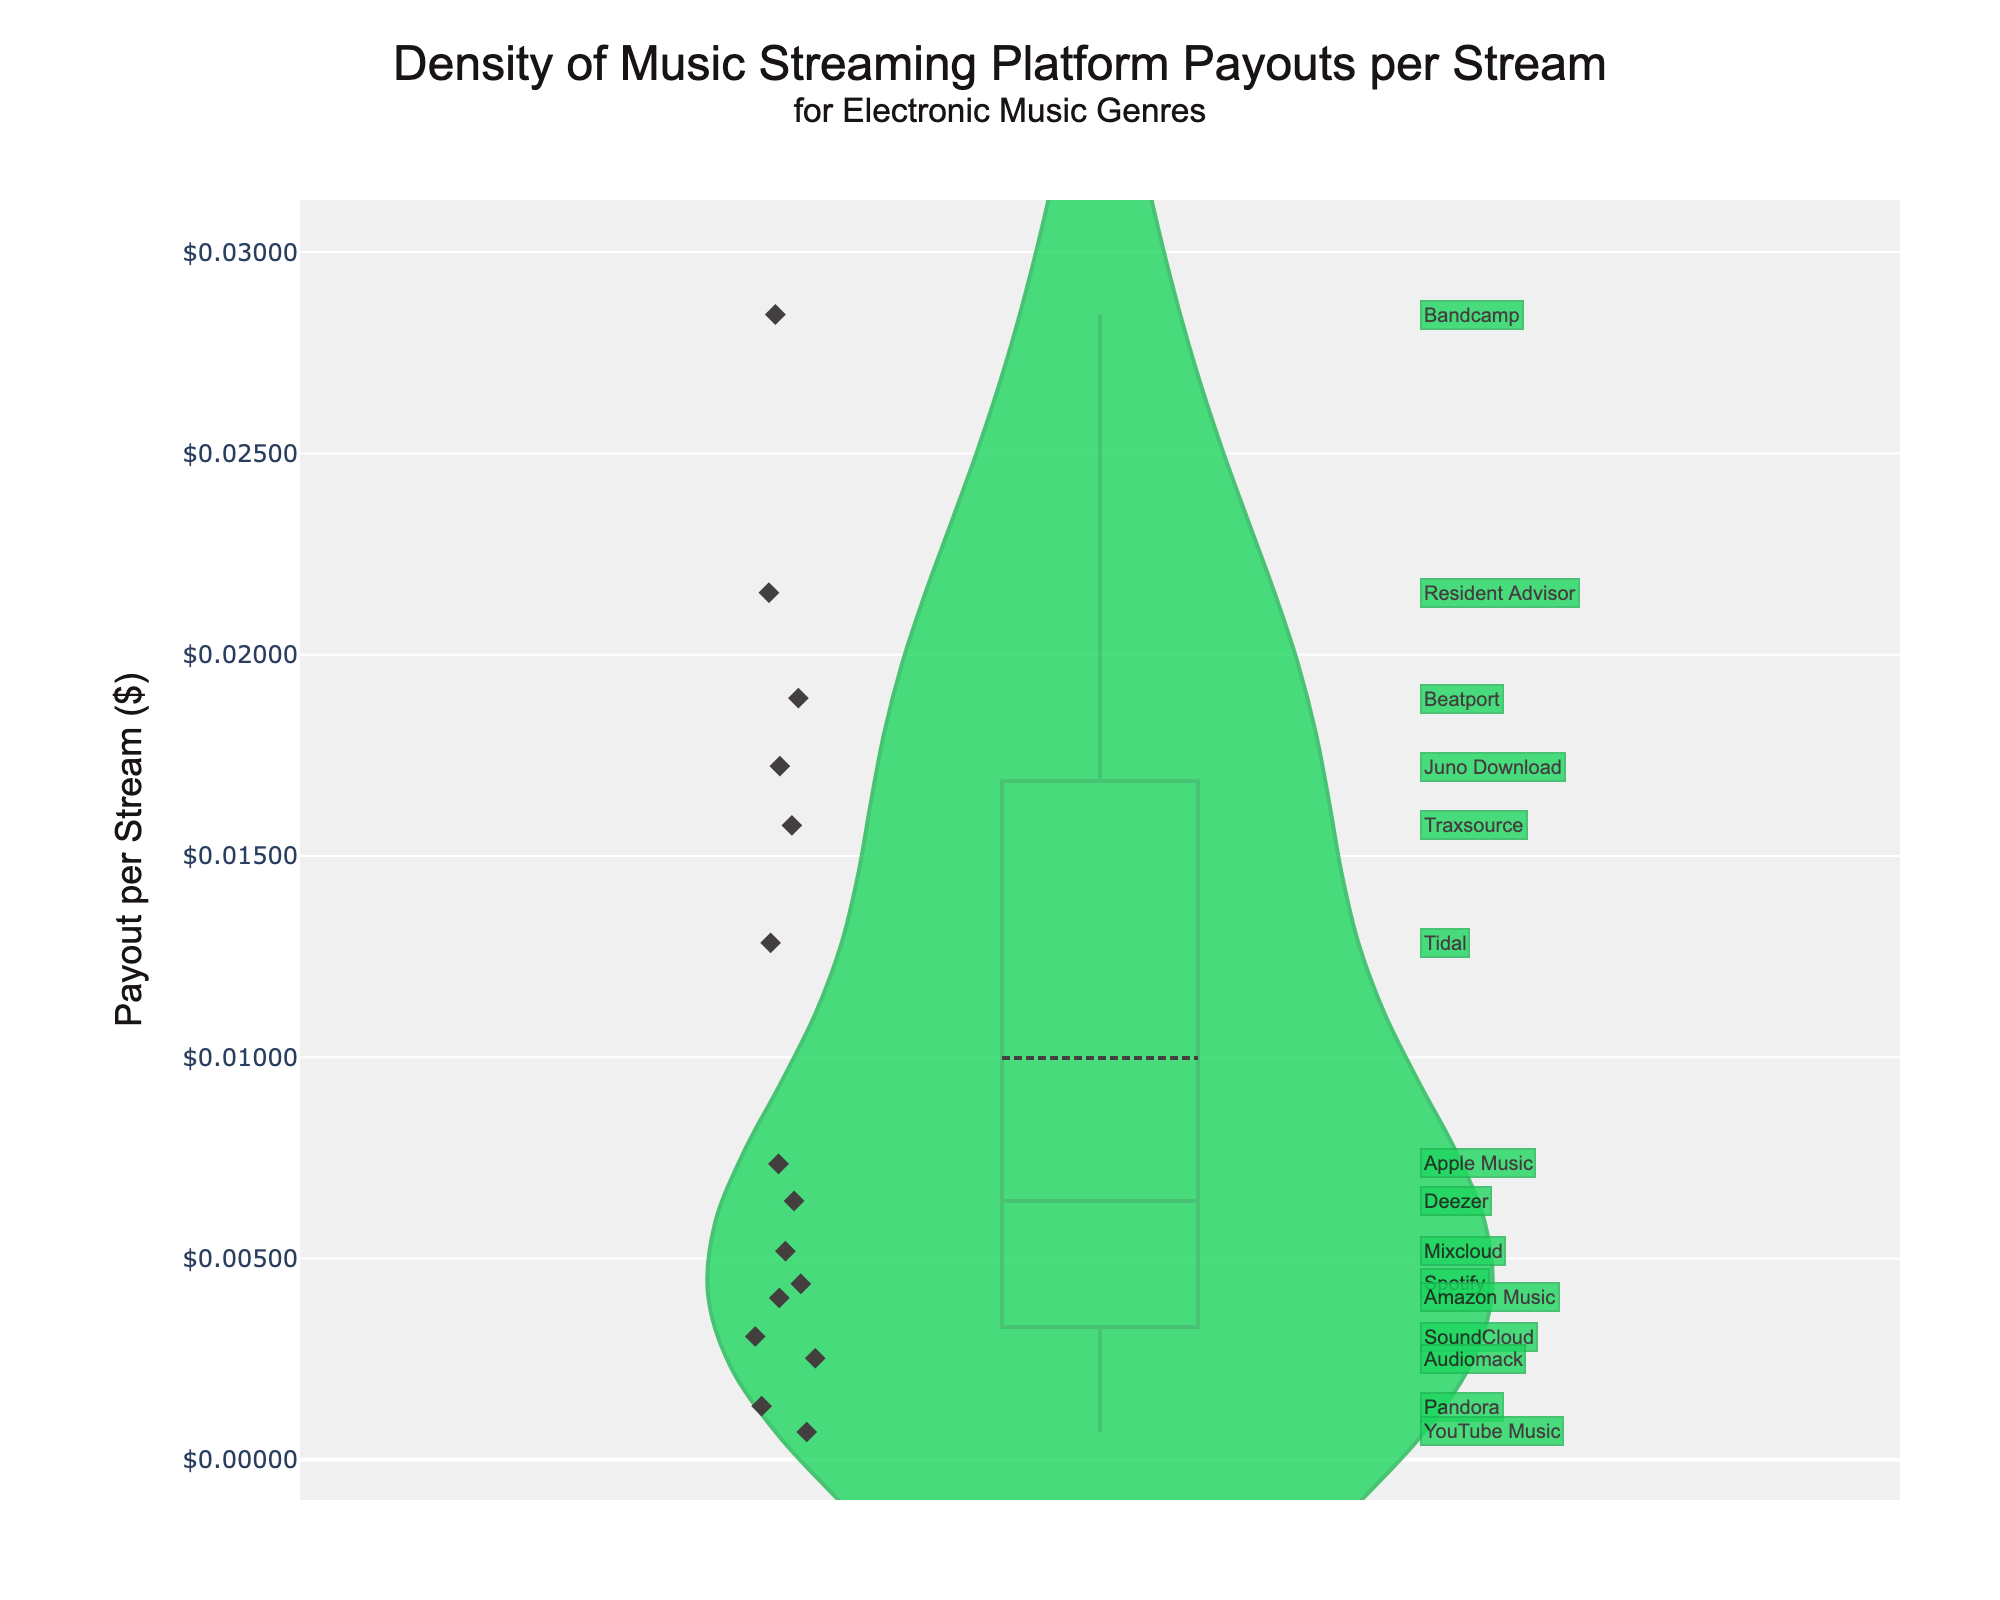What is the highest payout per stream among the platforms? The highest point in the density plot represents the largest payout per stream. From the plot, we can note that Bandcamp has the highest value.
Answer: Bandcamp What is the lowest payout per stream depicted in the figure? The lowest value is indicated by the lowest point in the density plot. YouTube Music has the lowest payout per stream.
Answer: YouTube Music Which platform has a payout per stream closest to $0.01? By looking at the points around the $0.01 mark on the y-axis, we see that Tidal has a payout slightly above $0.01.
Answer: Tidal How does the payout of Spotify compare to that of Apple Music? Observing the plot, Spotify's payout per stream is lower than that of Apple Music. This is seen by comparing their respective points on the y-axis.
Answer: Lower What is the mean payout per stream across all platforms? The density plot includes a visible mean line. The mean line is slightly above the $0.01 mark. More precisely, it's just under $0.01.
Answer: slightly under $0.01 Which platform offers a higher payout per stream: Beatport or Juno Download? The y-axis positions of Beatport and Juno Download need to be compared. Beatport is higher on the plot than Juno Download.
Answer: Beatport Which platform's point has the smallest deviation from the mean payout per stream? The platform's point that is closest to the mean line on the plot has the smallest deviation. Mixcloud appears nearest to the mean line.
Answer: Mixcloud How does the payout of Amazon Music compare to SoundCloud? By examining the y-axis positions, Amazon Music's payout per stream is higher than that of SoundCloud.
Answer: Higher What is the difference in payout per stream between Audiomack and Resident Advisor? The y-axis readings of Audiomack and Resident Advisor should be subtracted: Resident Advisor (0.02154) - Audiomack (0.00252) = 0.01902.
Answer: 0.01902 Which platforms have payouts above $0.02 per stream? Identify points above the $0.02 mark on the y-axis in the plot. These platforms are Bandcamp, Resident Advisor, Traxsource, and Beatport.
Answer: Bandcamp, Resident Advisor, Traxsource, Beatport 